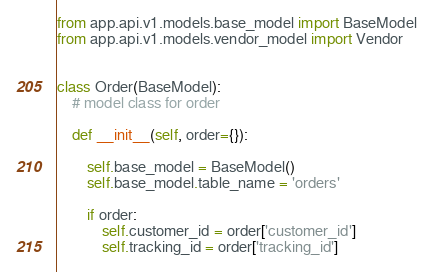<code> <loc_0><loc_0><loc_500><loc_500><_Python_>from app.api.v1.models.base_model import BaseModel
from app.api.v1.models.vendor_model import Vendor


class Order(BaseModel):
    # model class for order

    def __init__(self, order={}):
        
        self.base_model = BaseModel()
        self.base_model.table_name = 'orders'
        
        if order:
            self.customer_id = order['customer_id']
            self.tracking_id = order['tracking_id']</code> 